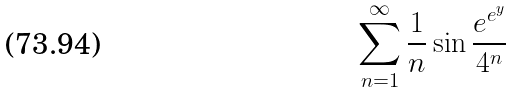Convert formula to latex. <formula><loc_0><loc_0><loc_500><loc_500>\sum _ { n = 1 } ^ { \infty } \frac { 1 } { n } \sin \frac { e ^ { e ^ { y } } } { 4 ^ { n } }</formula> 